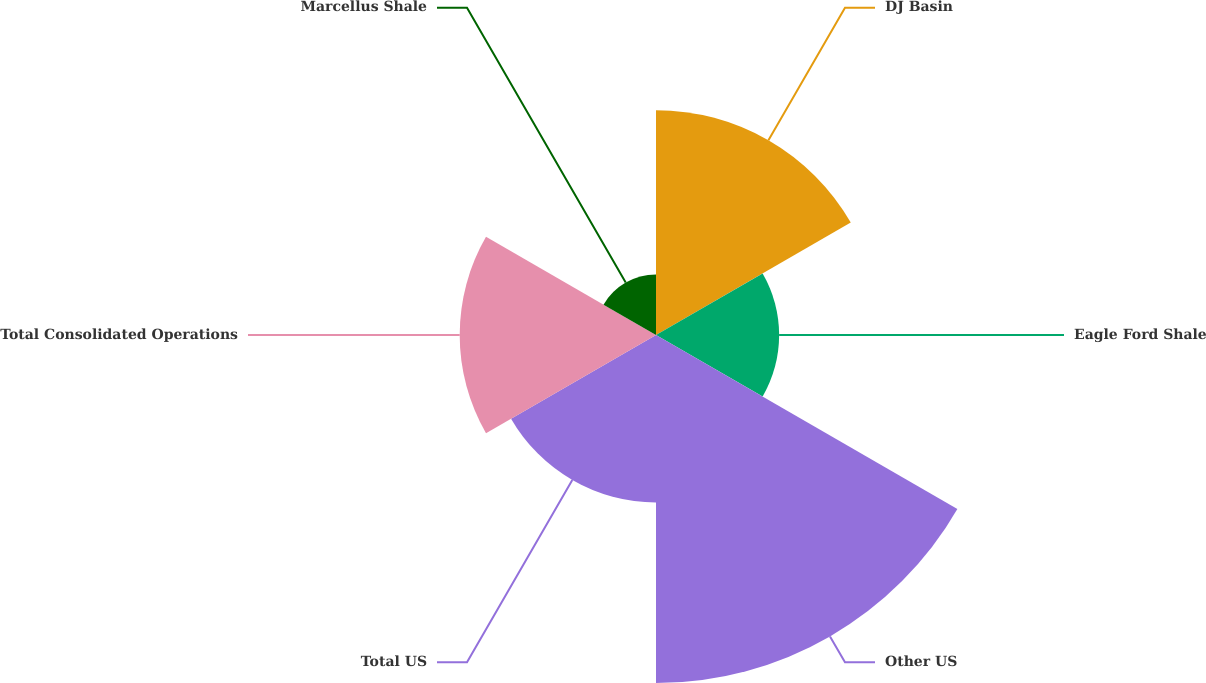Convert chart. <chart><loc_0><loc_0><loc_500><loc_500><pie_chart><fcel>DJ Basin<fcel>Eagle Ford Shale<fcel>Other US<fcel>Total US<fcel>Total Consolidated Operations<fcel>Marcellus Shale<nl><fcel>20.07%<fcel>10.99%<fcel>31.06%<fcel>14.94%<fcel>17.52%<fcel>5.41%<nl></chart> 